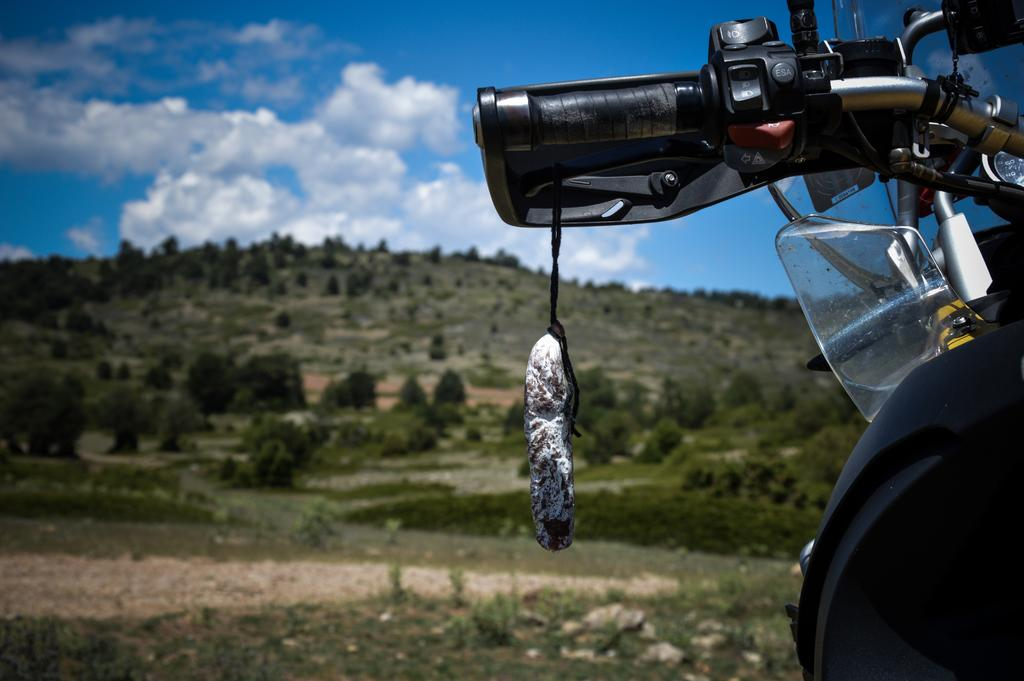What is the main subject in the image? There is a vehicle in the image. What is attached to the handle of the vehicle? Something is hanged on the handle of the vehicle. What can be seen in the background of the image? There are trees and a mountain visible in the background. What is the color of the sky in the image? The sky is blue and white in color. How many crates are stacked on the attention-grabbing blade in the image? There are no crates or blades present in the image. 